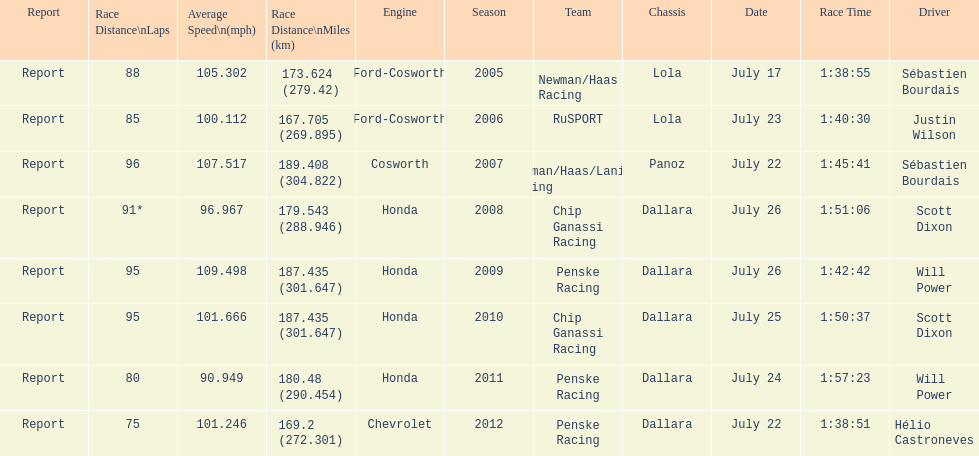How many flags other than france (the first flag) are represented? 3. 